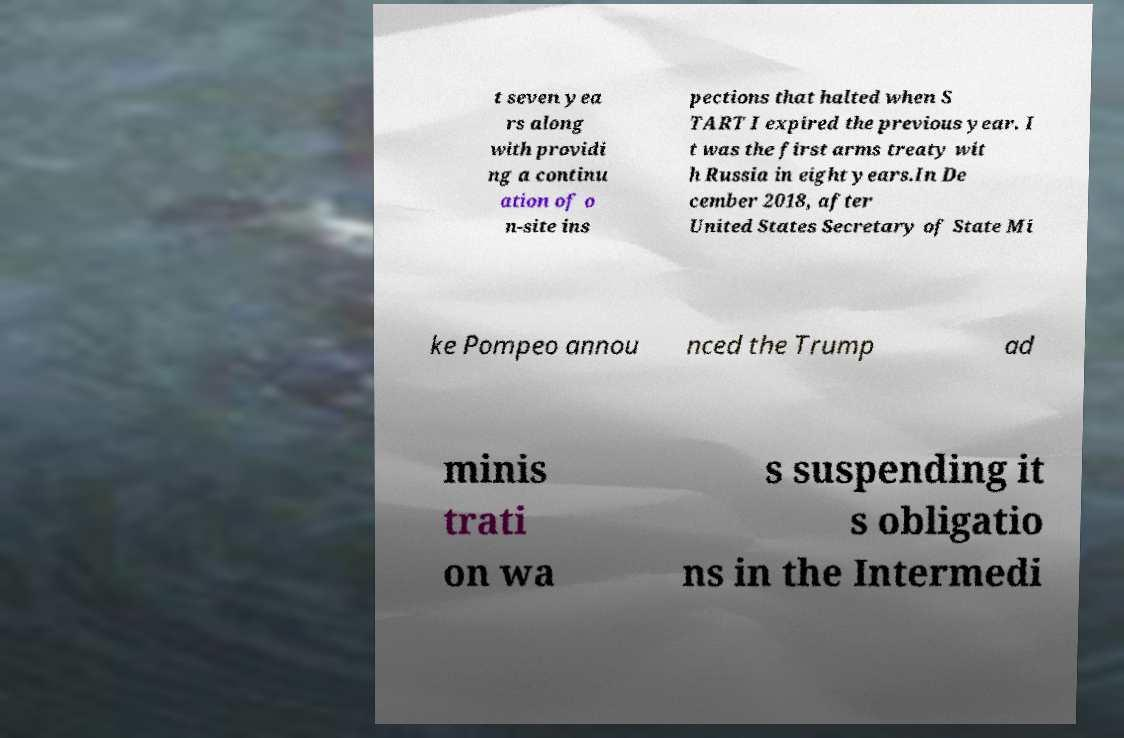Could you extract and type out the text from this image? t seven yea rs along with providi ng a continu ation of o n-site ins pections that halted when S TART I expired the previous year. I t was the first arms treaty wit h Russia in eight years.In De cember 2018, after United States Secretary of State Mi ke Pompeo annou nced the Trump ad minis trati on wa s suspending it s obligatio ns in the Intermedi 